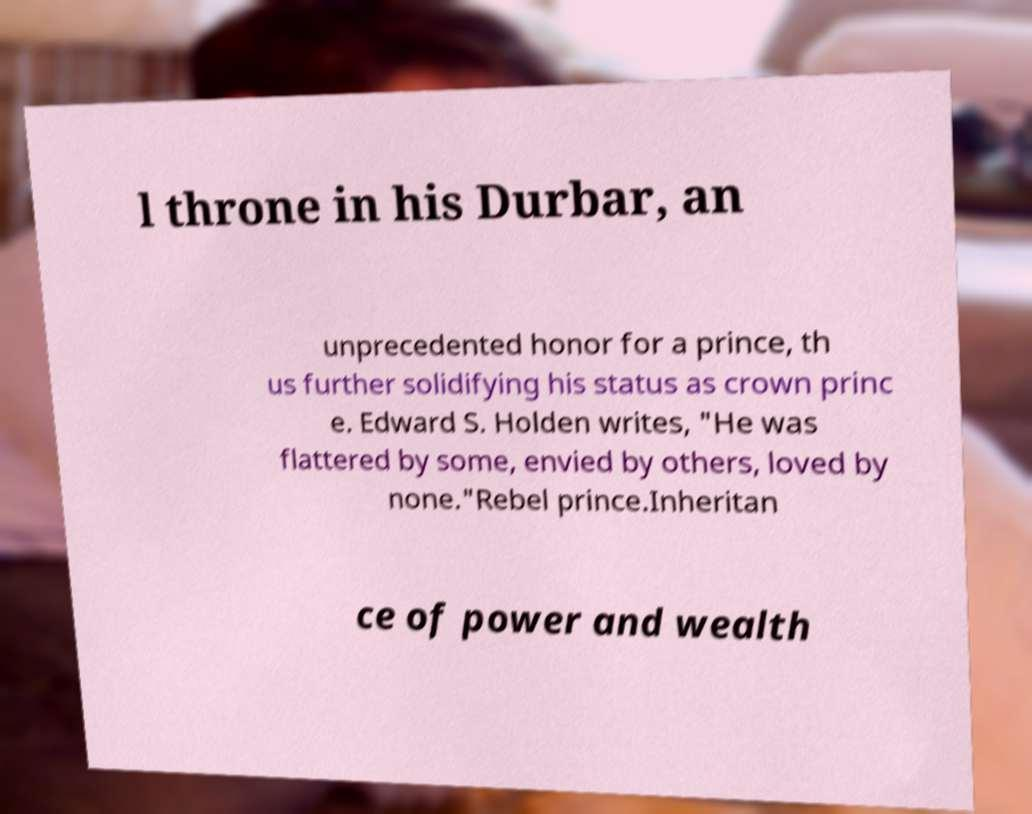What messages or text are displayed in this image? I need them in a readable, typed format. l throne in his Durbar, an unprecedented honor for a prince, th us further solidifying his status as crown princ e. Edward S. Holden writes, "He was flattered by some, envied by others, loved by none."Rebel prince.Inheritan ce of power and wealth 